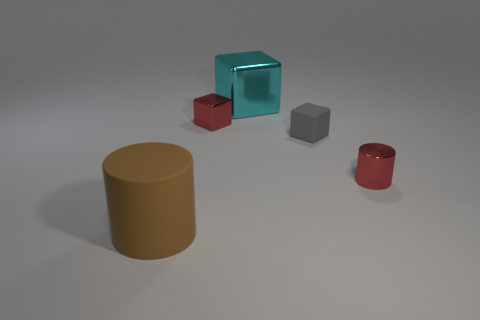The cube that is the same color as the tiny cylinder is what size?
Make the answer very short. Small. There is a tiny red object that is the same shape as the brown matte thing; what is it made of?
Offer a very short reply. Metal. There is a tiny red metal object on the left side of the large object that is behind the big matte object; is there a brown cylinder that is in front of it?
Give a very brief answer. Yes. Is the shape of the cyan thing the same as the red metal object that is to the right of the tiny shiny block?
Your answer should be compact. No. Is there any other thing of the same color as the tiny metallic cube?
Your response must be concise. Yes. Does the metallic object on the left side of the big cyan metallic block have the same color as the cylinder to the right of the big metallic object?
Offer a terse response. Yes. Is there a large brown cylinder?
Give a very brief answer. Yes. Are there any cylinders that have the same material as the tiny gray thing?
Ensure brevity in your answer.  Yes. The metallic cylinder is what color?
Provide a succinct answer. Red. The small metal object that is the same color as the small cylinder is what shape?
Give a very brief answer. Cube. 